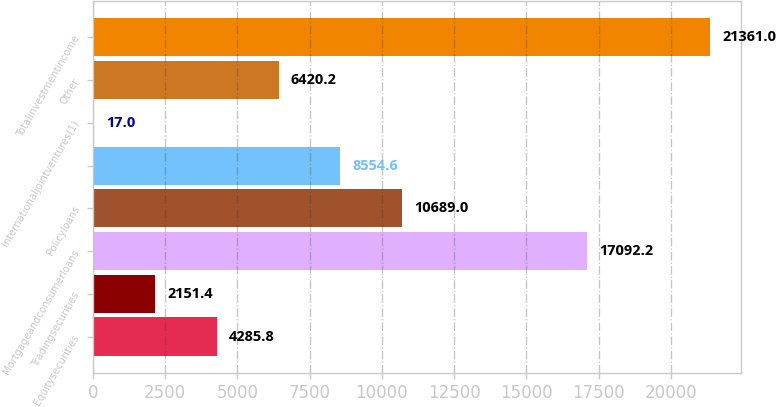Convert chart to OTSL. <chart><loc_0><loc_0><loc_500><loc_500><bar_chart><fcel>Equitysecurities<fcel>Tradingsecurities<fcel>Mortgageandconsumerloans<fcel>Policyloans<fcel>Unnamed: 4<fcel>Internationaljointventures(1)<fcel>Other<fcel>Totalinvestmentincome<nl><fcel>4285.8<fcel>2151.4<fcel>17092.2<fcel>10689<fcel>8554.6<fcel>17<fcel>6420.2<fcel>21361<nl></chart> 